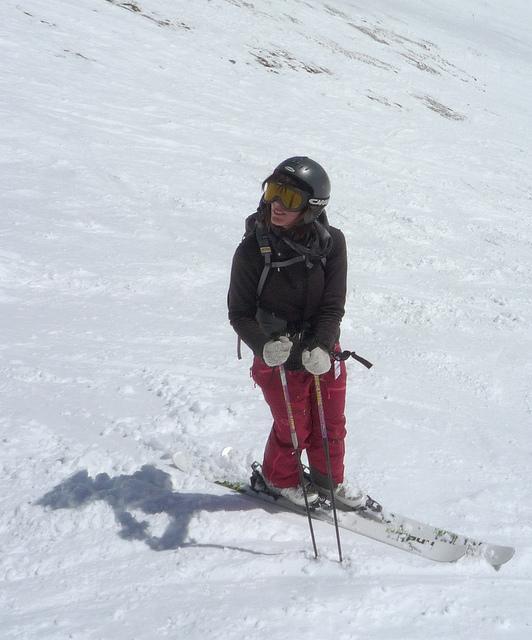How many chairs are behind the pole?
Give a very brief answer. 0. 